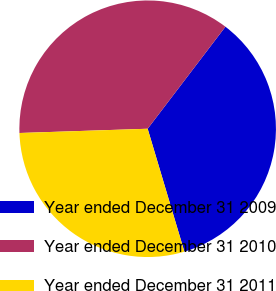Convert chart. <chart><loc_0><loc_0><loc_500><loc_500><pie_chart><fcel>Year ended December 31 2009<fcel>Year ended December 31 2010<fcel>Year ended December 31 2011<nl><fcel>35.01%<fcel>35.89%<fcel>29.09%<nl></chart> 